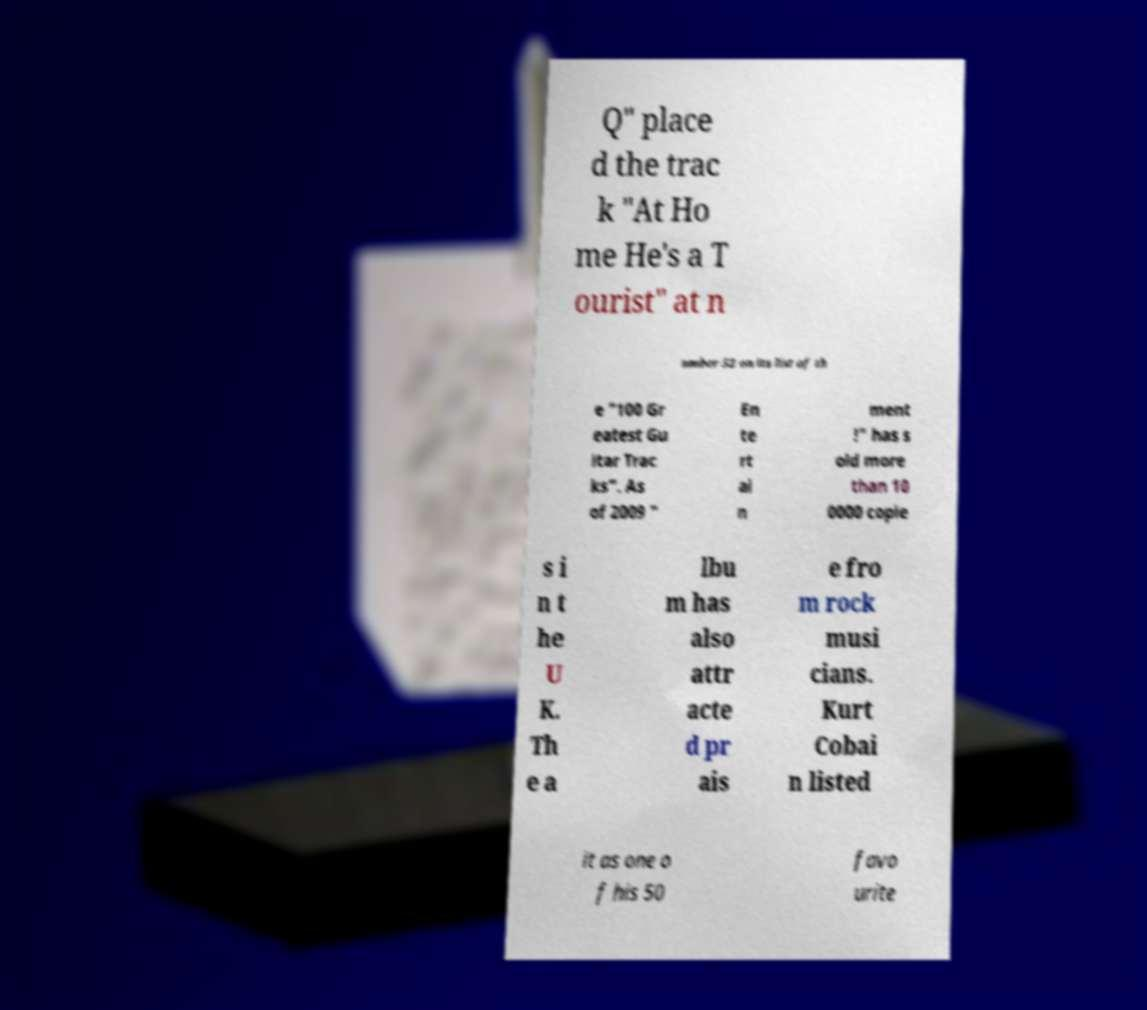I need the written content from this picture converted into text. Can you do that? Q" place d the trac k "At Ho me He's a T ourist" at n umber 52 on its list of th e "100 Gr eatest Gu itar Trac ks". As of 2009 " En te rt ai n ment !" has s old more than 10 0000 copie s i n t he U K. Th e a lbu m has also attr acte d pr ais e fro m rock musi cians. Kurt Cobai n listed it as one o f his 50 favo urite 